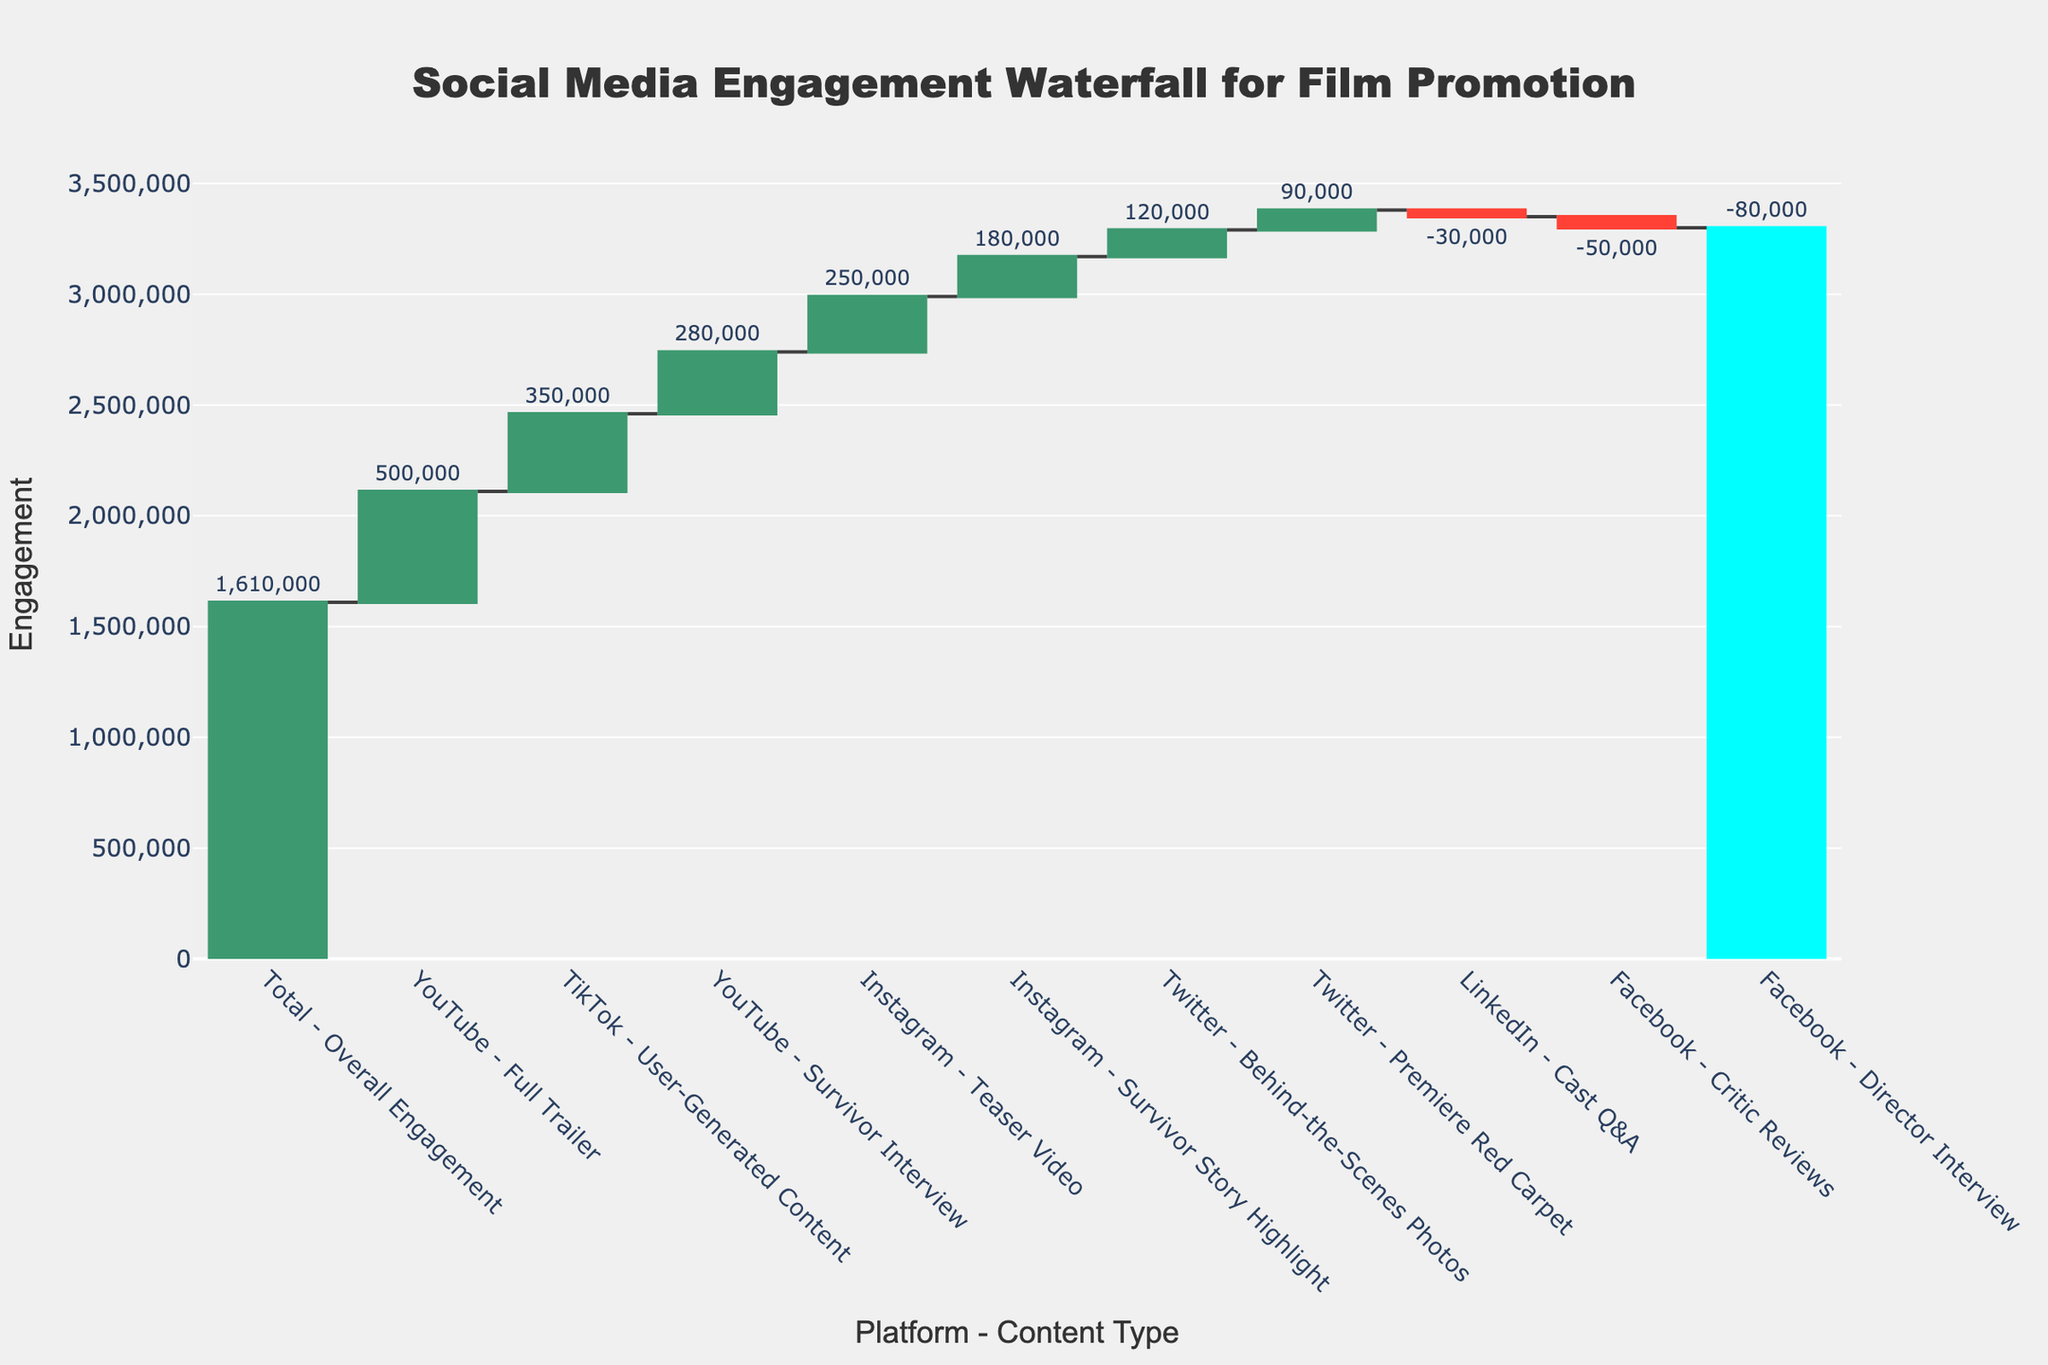What is the overall engagement from all social media platforms and content types? The total engagement is represented by the final bar in the Waterfall Chart, which sums up the gains and losses from various platforms and content types.
Answer: 1,610,000 Which platform and content type combination had the highest engagement? The bar with the highest positive value indicates the highest engagement. According to the data, YouTube with the Full Trailer has the highest engagement.
Answer: YouTube - Full Trailer Which platform and content type combination had the most negative engagement? The bar with the lowest value indicates the most negative engagement. According to the data, Facebook with the Director Interview has the most negative engagement.
Answer: Facebook - Director Interview What is the engagement difference between the YouTube Full Trailer and the Facebook Director Interview? The YouTube Full Trailer has 500,000 engagements and the Facebook Director Interview has -80,000 engagements. The difference is 500,000 - (-80,000) = 580,000.
Answer: 580,000 Compare the engagement between Instagram Teaser Video and TikTok User-Generated Content. Which one is higher and by how much? The engagement for Instagram Teaser Video is 250,000 and for TikTok User-Generated Content is 350,000. The difference is 350,000 - 250,000 = 100,000. TikTok User-Generated Content is higher.
Answer: TikTok User-Generated Content by 100,000 What is the average engagement for all negative engagement bars? The negative engagement bars are: Facebook - Director Interview (-80,000), Facebook - Critic Reviews (-50,000), and LinkedIn - Cast Q&A (-30,000). The average is (-80,000 + -50,000 + -30,000) / 3 = -160,000 / 3 = -53,333.33.
Answer: -53,333.33 What percentage increase in engagement does TikTok User-Generated Content represent compared to Twitter Premiere Red Carpet? The engagement for TikTok User-Generated Content is 350,000 and for Twitter Premiere Red Carpet is 90,000. The percentage increase is ((350,000 - 90,000) / 90,000) * 100 = (260,000 / 90,000) * 100 ≈ 288.9%.
Answer: ≈ 288.9% Which two platforms and content types have engagements that sum up closest to zero when combined? Facebook - Director Interview’s engagement is -80,000 and Instagram's Survivor Story Highlight's engagement is 180,000. Combined they sum up to 100,000. However, checking all combinations, the closest to zero is LinkedIn - Cast Q&A (-30,000) and Facebook - Critic Reviews (-50,000) summing up to -80,000, which is not close to zero.
Answer: None, sum up closest to zero with the given data How many platforms and content types had positive engagement values? By counting the bars with positive values in the Waterfall Chart, we see: Instagram Teaser Video (250,000), Twitter Behind-the-Scenes Photos (120,000), YouTube Full Trailer (500,000), TikTok User-Generated Content (350,000), Instagram Survivor Story Highlight (180,000), Twitter Premiere Red Carpet (90,000), and YouTube Survivor Interview (280,000). Seven in total.
Answer: 7 